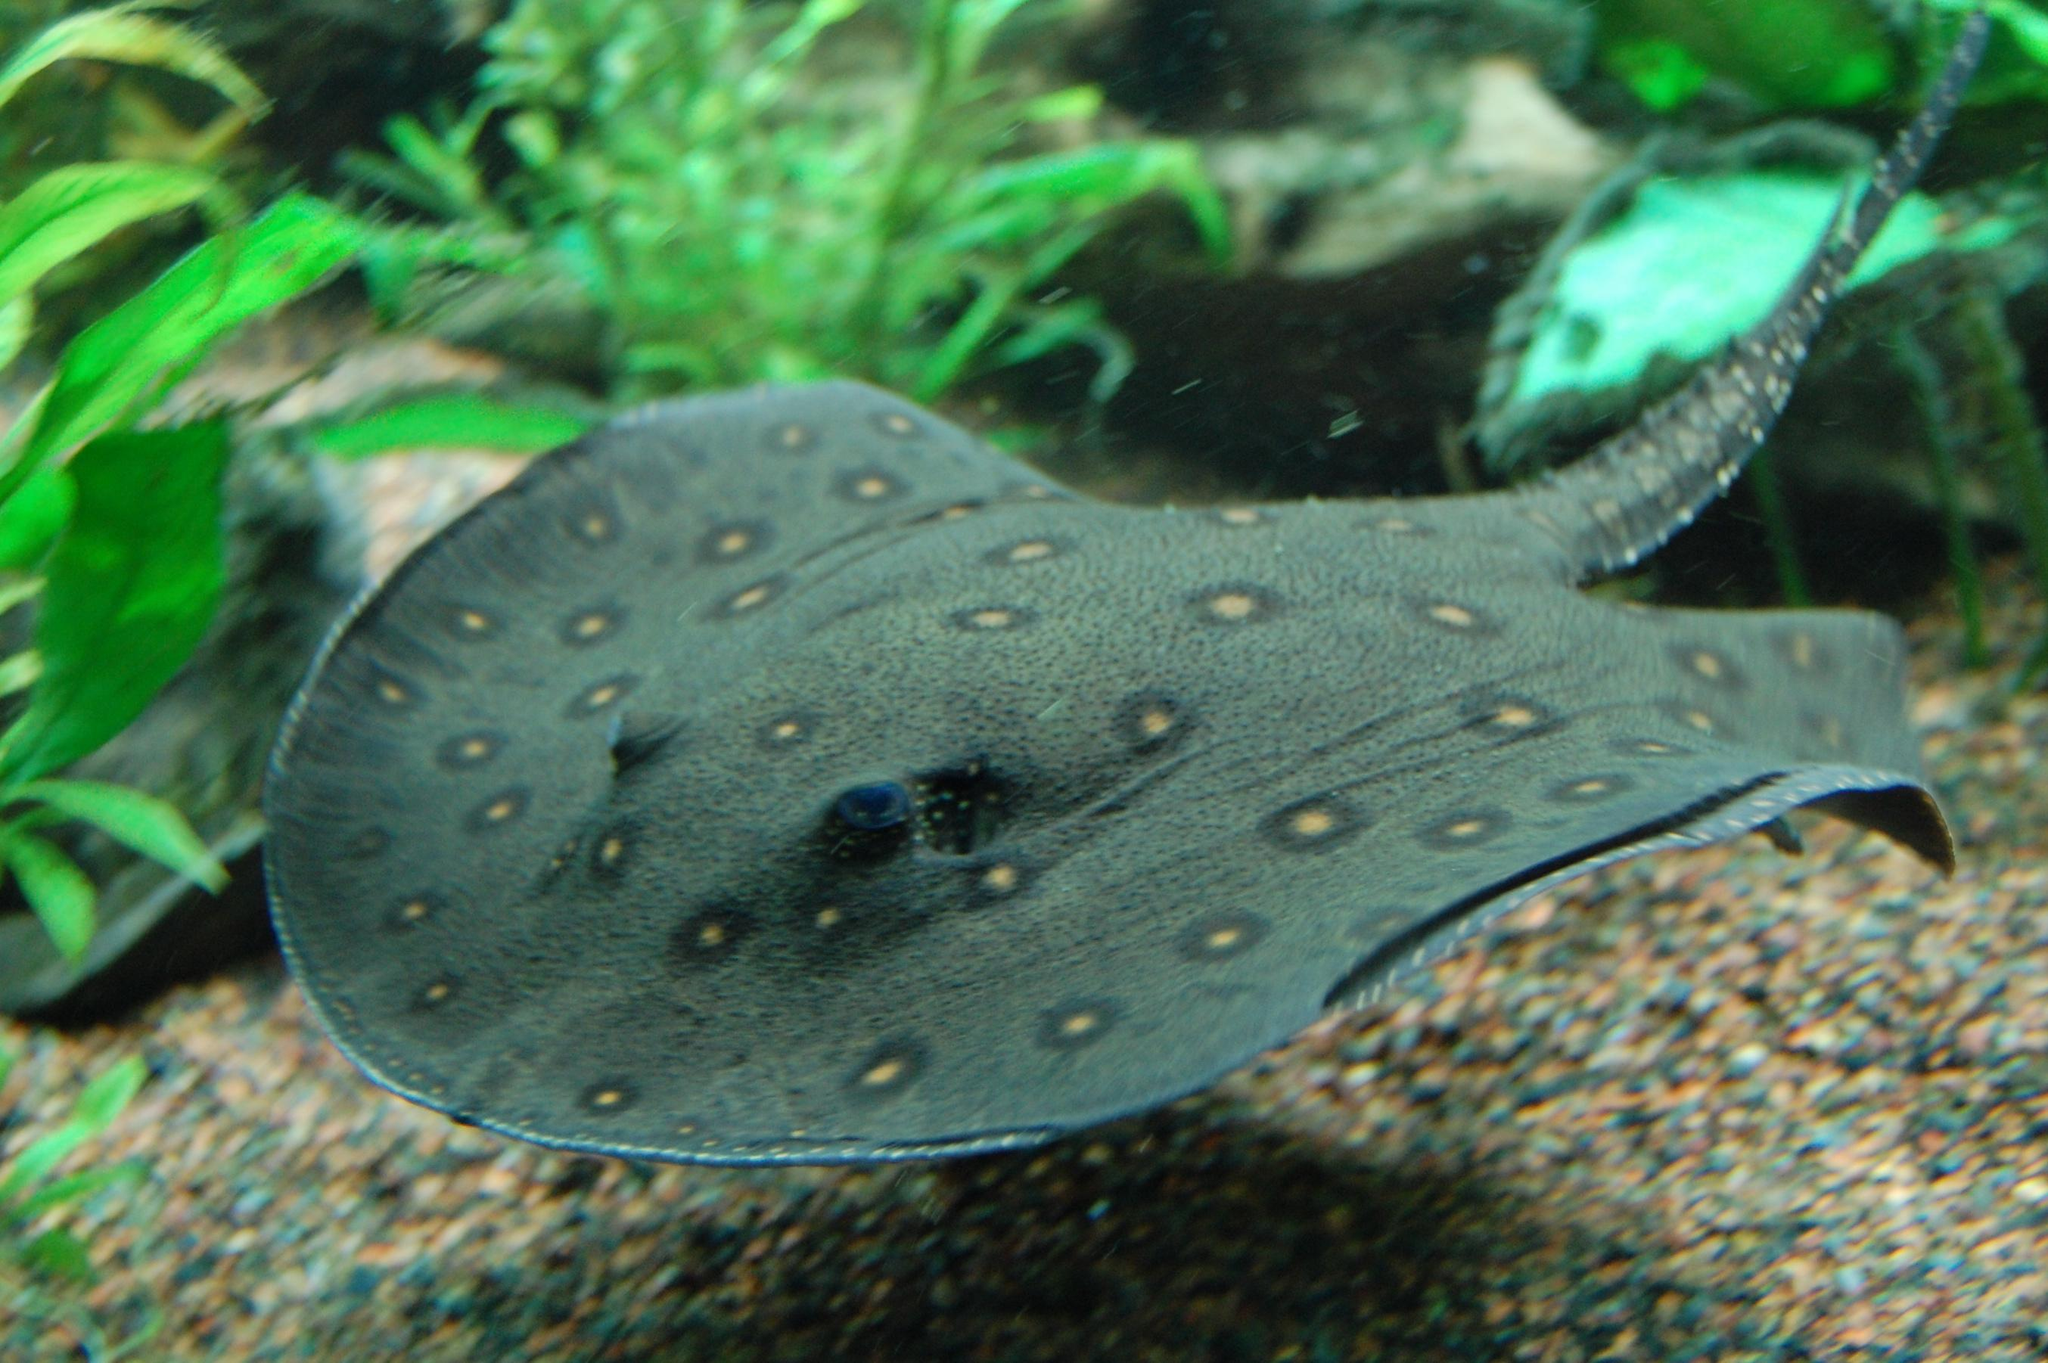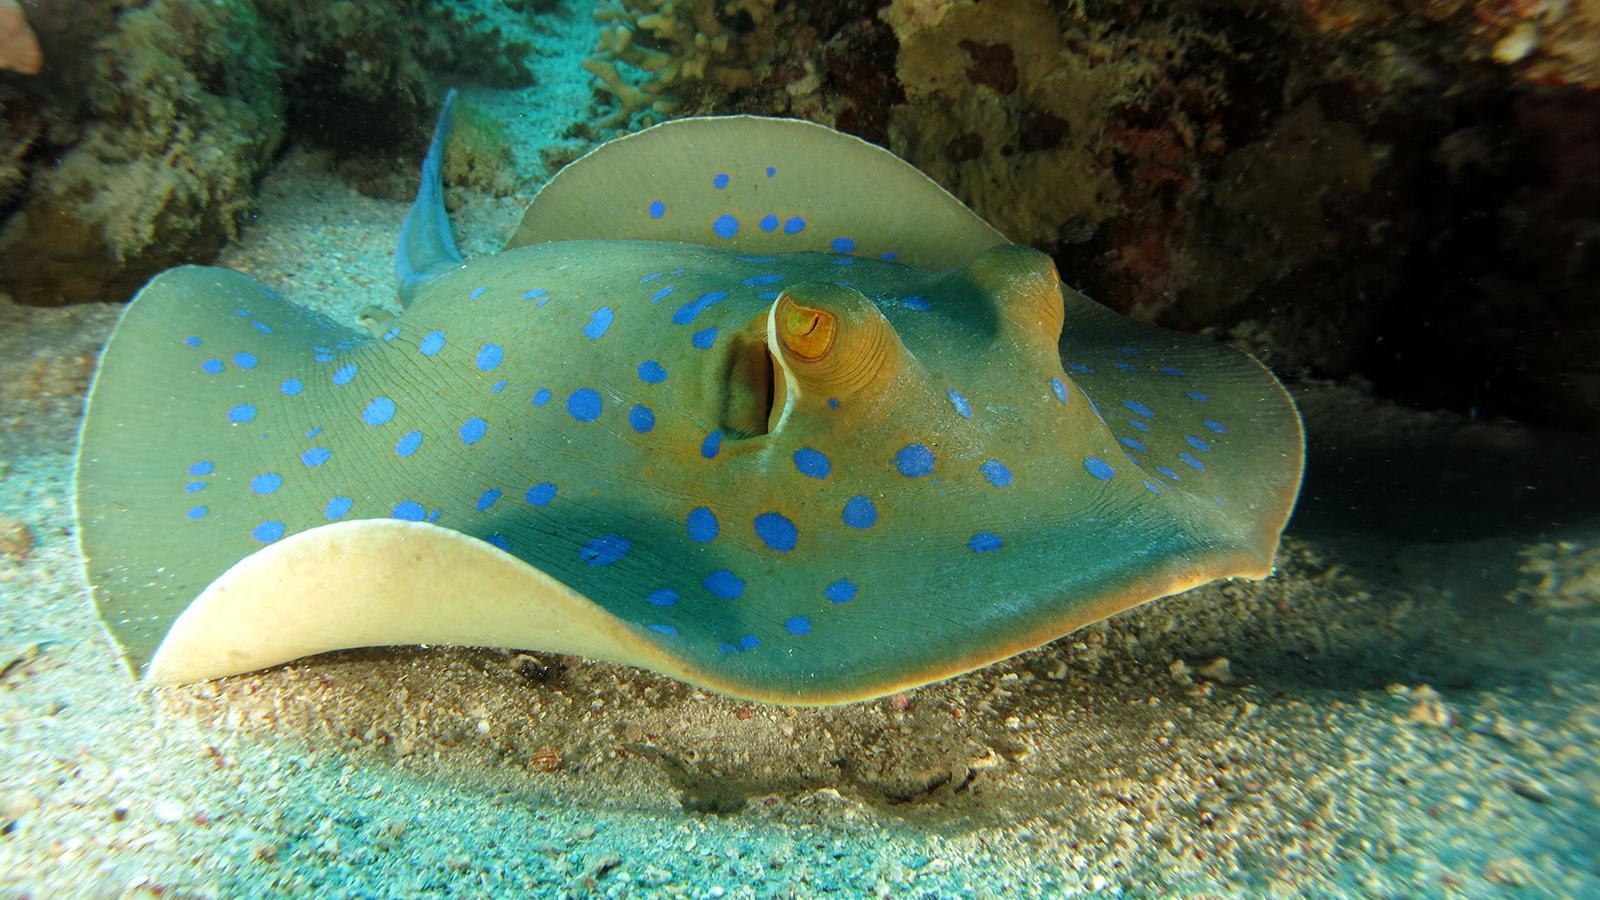The first image is the image on the left, the second image is the image on the right. For the images displayed, is the sentence "All stingrays shown have distinctive colorful dot patterns." factually correct? Answer yes or no. Yes. 